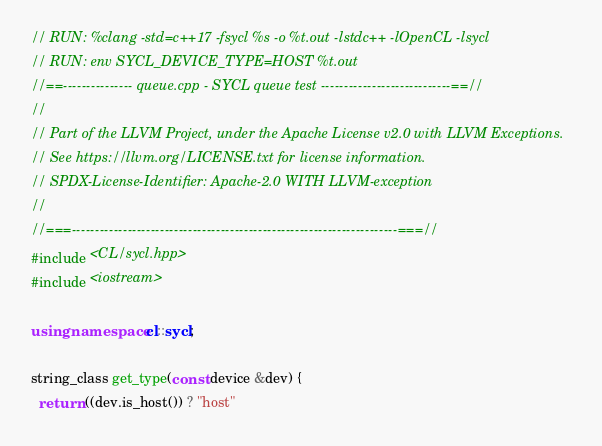Convert code to text. <code><loc_0><loc_0><loc_500><loc_500><_C++_>// RUN: %clang -std=c++17 -fsycl %s -o %t.out -lstdc++ -lOpenCL -lsycl
// RUN: env SYCL_DEVICE_TYPE=HOST %t.out
//==--------------- queue.cpp - SYCL queue test ----------------------------==//
//
// Part of the LLVM Project, under the Apache License v2.0 with LLVM Exceptions.
// See https://llvm.org/LICENSE.txt for license information.
// SPDX-License-Identifier: Apache-2.0 WITH LLVM-exception
//
//===----------------------------------------------------------------------===//
#include <CL/sycl.hpp>
#include <iostream>

using namespace cl::sycl;

string_class get_type(const device &dev) {
  return ((dev.is_host()) ? "host"</code> 